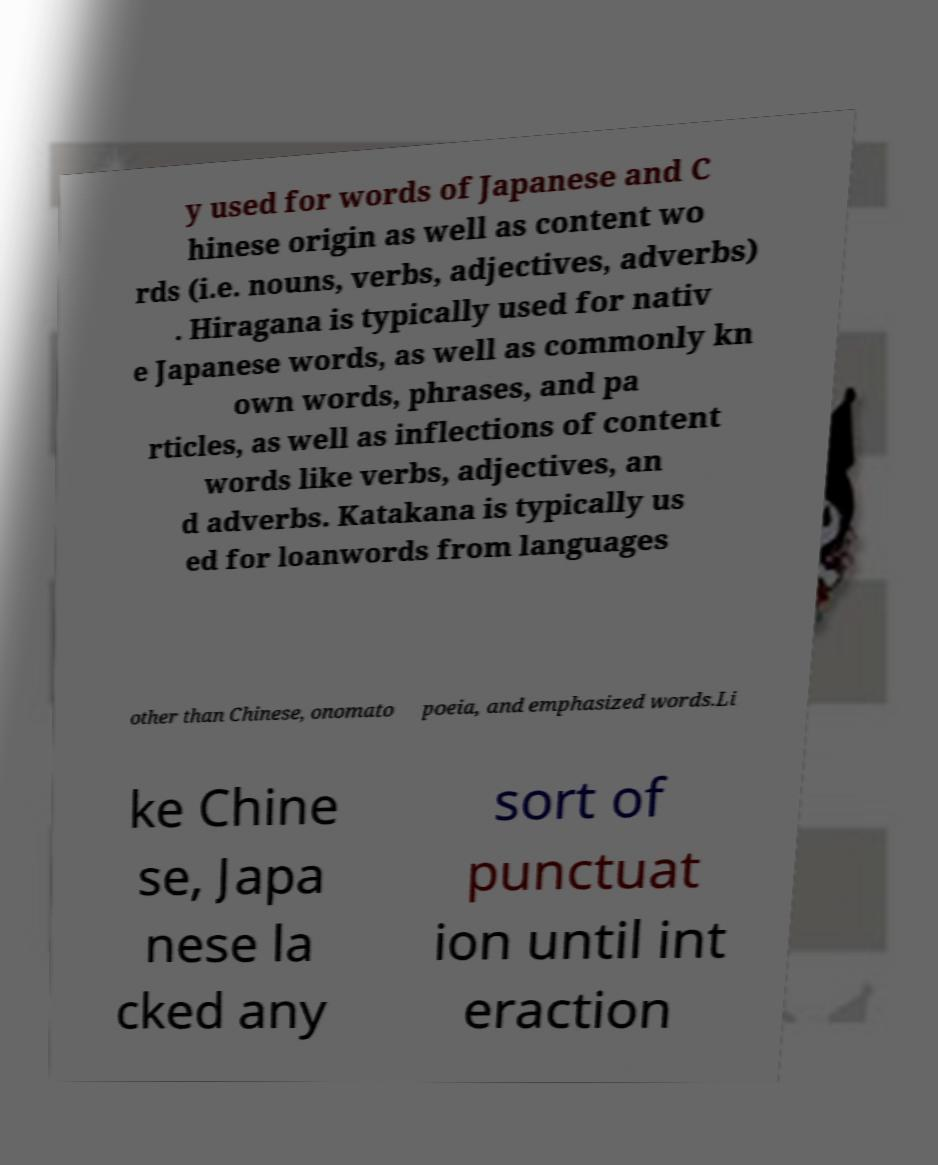What messages or text are displayed in this image? I need them in a readable, typed format. y used for words of Japanese and C hinese origin as well as content wo rds (i.e. nouns, verbs, adjectives, adverbs) . Hiragana is typically used for nativ e Japanese words, as well as commonly kn own words, phrases, and pa rticles, as well as inflections of content words like verbs, adjectives, an d adverbs. Katakana is typically us ed for loanwords from languages other than Chinese, onomato poeia, and emphasized words.Li ke Chine se, Japa nese la cked any sort of punctuat ion until int eraction 